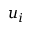Convert formula to latex. <formula><loc_0><loc_0><loc_500><loc_500>u _ { i }</formula> 